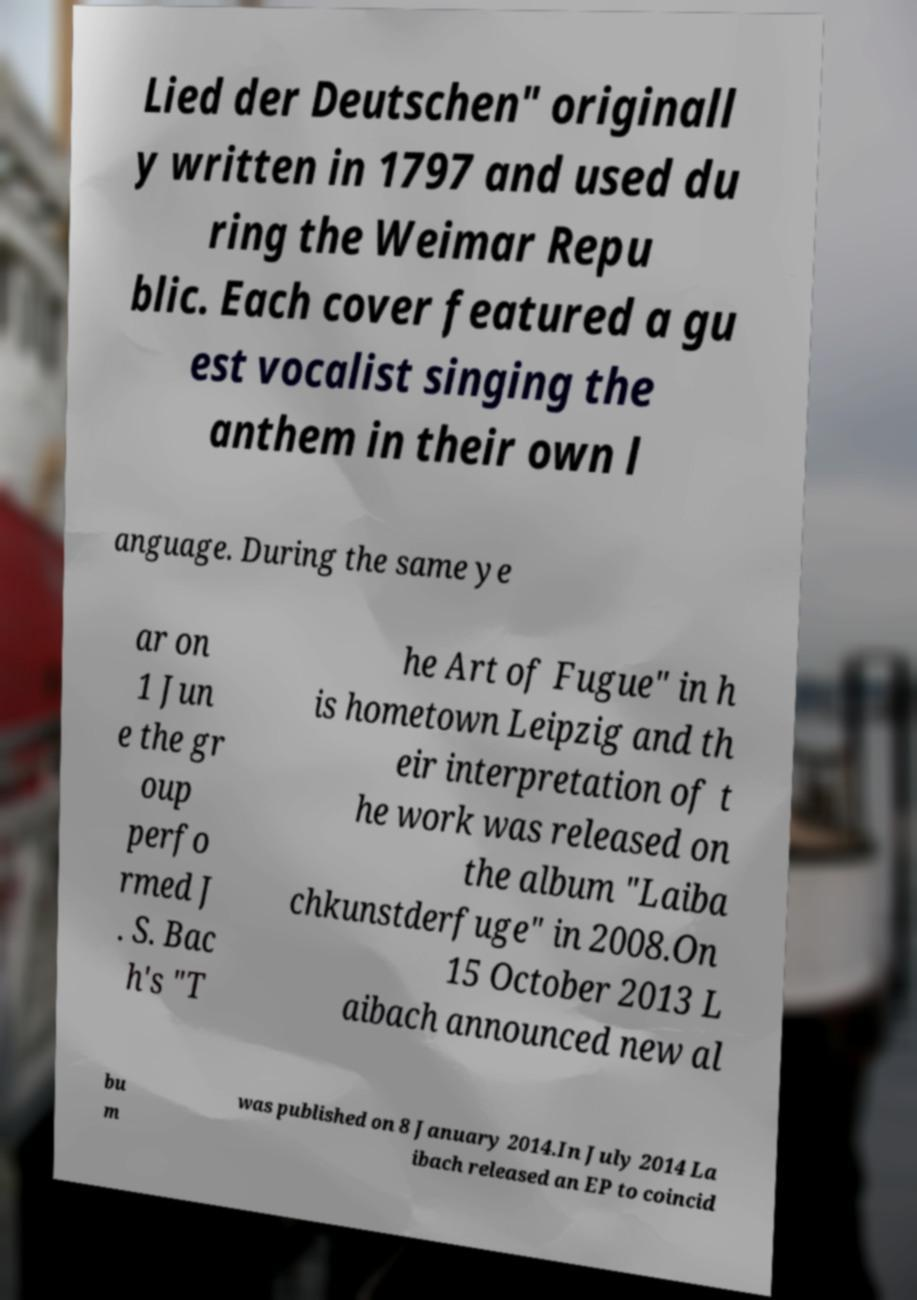Can you read and provide the text displayed in the image?This photo seems to have some interesting text. Can you extract and type it out for me? Lied der Deutschen" originall y written in 1797 and used du ring the Weimar Repu blic. Each cover featured a gu est vocalist singing the anthem in their own l anguage. During the same ye ar on 1 Jun e the gr oup perfo rmed J . S. Bac h's "T he Art of Fugue" in h is hometown Leipzig and th eir interpretation of t he work was released on the album "Laiba chkunstderfuge" in 2008.On 15 October 2013 L aibach announced new al bu m was published on 8 January 2014.In July 2014 La ibach released an EP to coincid 